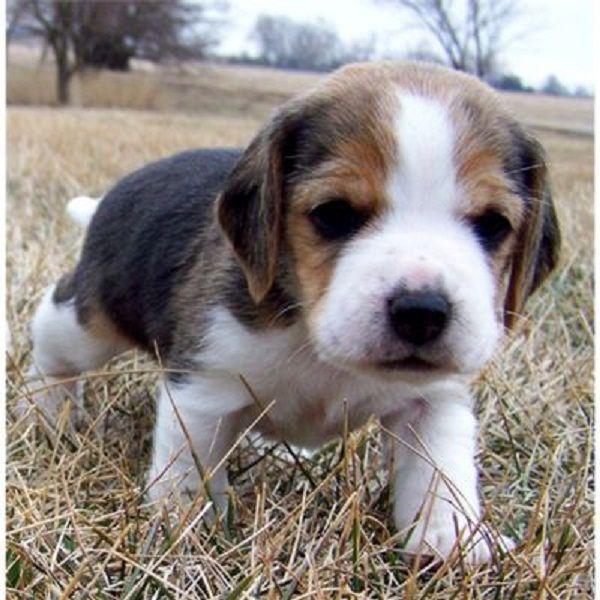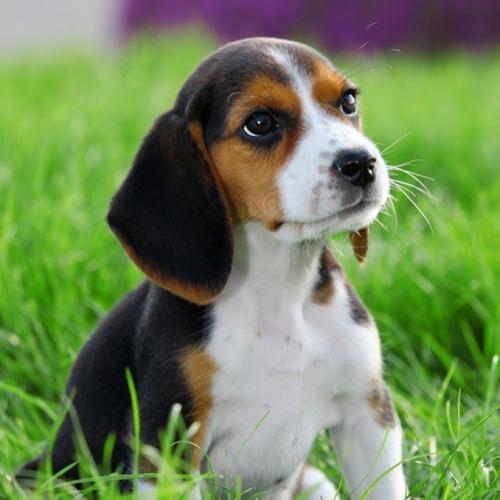The first image is the image on the left, the second image is the image on the right. Considering the images on both sides, is "There are no more than 3 puppies in total." valid? Answer yes or no. Yes. The first image is the image on the left, the second image is the image on the right. For the images shown, is this caption "There are more dogs in the right image than in the left image." true? Answer yes or no. No. 